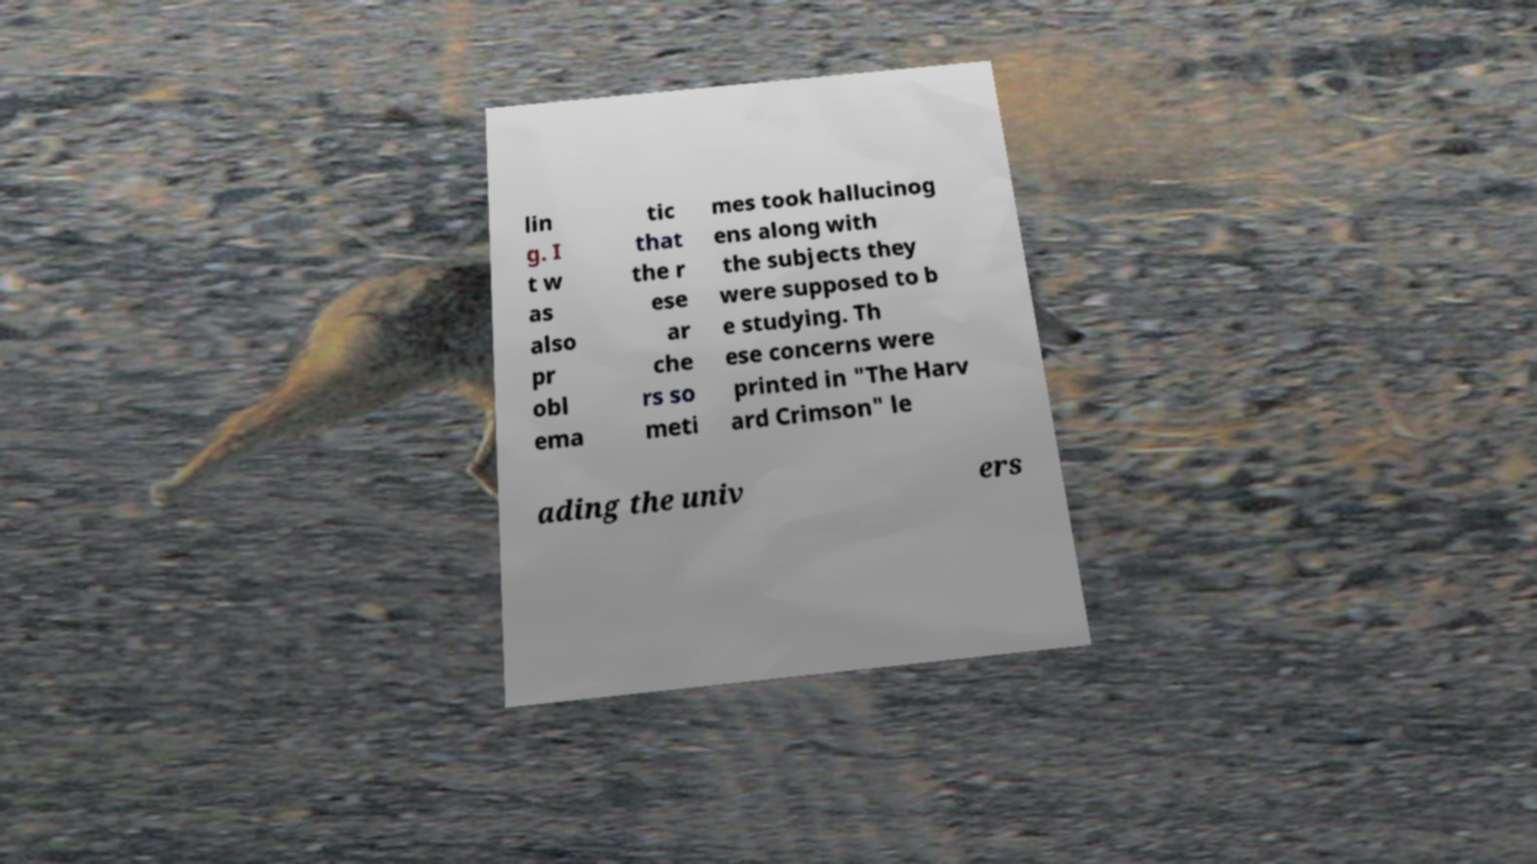Can you read and provide the text displayed in the image?This photo seems to have some interesting text. Can you extract and type it out for me? lin g. I t w as also pr obl ema tic that the r ese ar che rs so meti mes took hallucinog ens along with the subjects they were supposed to b e studying. Th ese concerns were printed in "The Harv ard Crimson" le ading the univ ers 